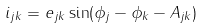<formula> <loc_0><loc_0><loc_500><loc_500>i _ { j k } = e _ { j k } \sin ( \phi _ { j } - \phi _ { k } - A _ { j k } )</formula> 